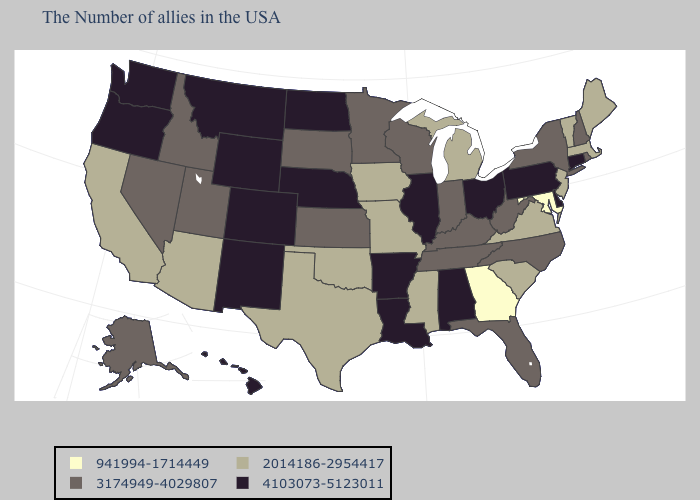Does Alaska have the same value as Connecticut?
Write a very short answer. No. Name the states that have a value in the range 3174949-4029807?
Be succinct. Rhode Island, New Hampshire, New York, North Carolina, West Virginia, Florida, Kentucky, Indiana, Tennessee, Wisconsin, Minnesota, Kansas, South Dakota, Utah, Idaho, Nevada, Alaska. Name the states that have a value in the range 941994-1714449?
Write a very short answer. Maryland, Georgia. Does the first symbol in the legend represent the smallest category?
Be succinct. Yes. Does Indiana have the same value as Iowa?
Be succinct. No. Among the states that border Indiana , which have the highest value?
Quick response, please. Ohio, Illinois. Name the states that have a value in the range 4103073-5123011?
Short answer required. Connecticut, Delaware, Pennsylvania, Ohio, Alabama, Illinois, Louisiana, Arkansas, Nebraska, North Dakota, Wyoming, Colorado, New Mexico, Montana, Washington, Oregon, Hawaii. Name the states that have a value in the range 941994-1714449?
Keep it brief. Maryland, Georgia. Does Michigan have the highest value in the MidWest?
Concise answer only. No. Which states hav the highest value in the Northeast?
Give a very brief answer. Connecticut, Pennsylvania. What is the value of Delaware?
Give a very brief answer. 4103073-5123011. Among the states that border Mississippi , which have the highest value?
Write a very short answer. Alabama, Louisiana, Arkansas. What is the value of North Carolina?
Write a very short answer. 3174949-4029807. Among the states that border Washington , which have the highest value?
Write a very short answer. Oregon. 